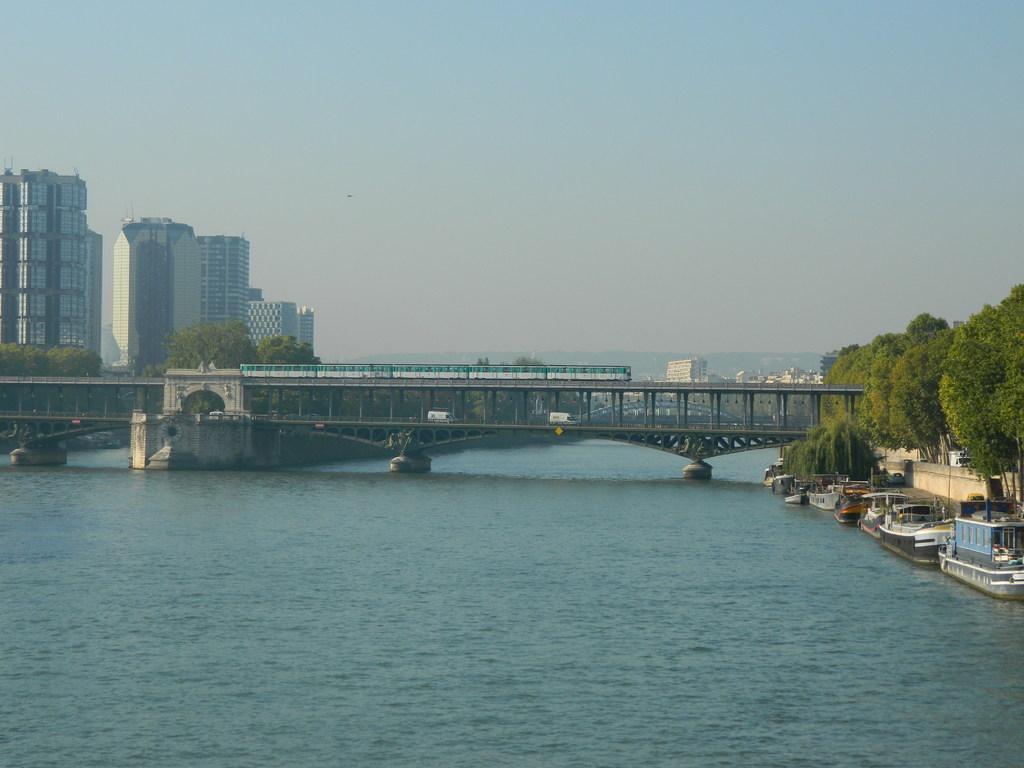How would you summarize this image in a sentence or two? In this image I can see few boards on the water. In the background I can see train and vehicle on the bridge. On both sides I can see the trees. I can also see many buildings, mountains and the sky in the back. 